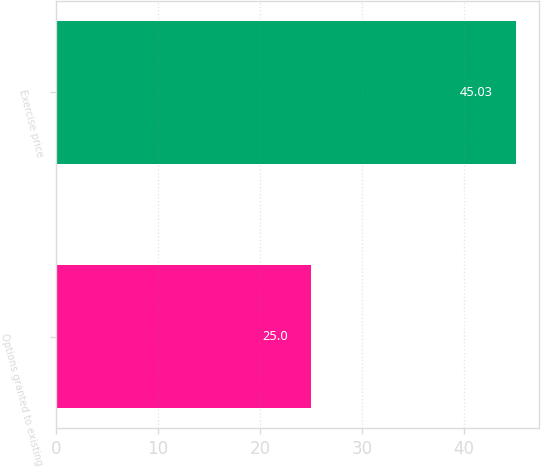<chart> <loc_0><loc_0><loc_500><loc_500><bar_chart><fcel>Options granted to existing<fcel>Exercise price<nl><fcel>25<fcel>45.03<nl></chart> 